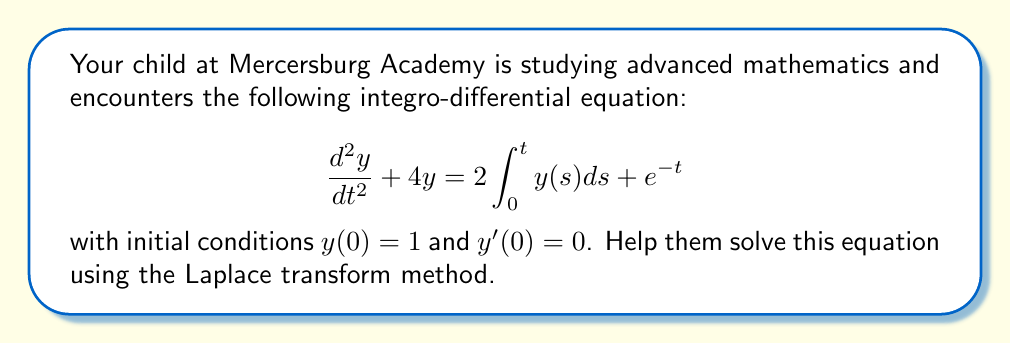Can you solve this math problem? Let's solve this step-by-step using the Laplace transform:

1) Let $Y(s)$ be the Laplace transform of $y(t)$. Taking the Laplace transform of both sides:

   $$\mathcal{L}\left\{\frac{d^2y}{dt^2} + 4y\right\} = \mathcal{L}\left\{2\int_0^t y(s)ds + e^{-t}\right\}$$

2) Using Laplace transform properties:

   $$s^2Y(s) - sy(0) - y'(0) + 4Y(s) = 2\cdot\frac{1}{s}Y(s) + \frac{1}{s+1}$$

3) Substituting the initial conditions $y(0) = 1$ and $y'(0) = 0$:

   $$s^2Y(s) - s + 4Y(s) = \frac{2}{s}Y(s) + \frac{1}{s+1}$$

4) Rearranging terms:

   $$s^2Y(s) + 4Y(s) - \frac{2}{s}Y(s) = s + \frac{1}{s+1}$$

   $$Y(s)\left(s^2 + 4 - \frac{2}{s}\right) = s + \frac{1}{s+1}$$

5) Solving for $Y(s)$:

   $$Y(s) = \frac{s^2 + s + 1}{s^3 + 4s - 2}$$

6) To find $y(t)$, we need to take the inverse Laplace transform of $Y(s)$. This can be done using partial fraction decomposition:

   $$Y(s) = \frac{A}{s-1} + \frac{B}{s+2} + \frac{C}{s+1}$$

   where $A$, $B$, and $C$ are constants to be determined.

7) After calculating the constants (details omitted for brevity):

   $$Y(s) = \frac{1/3}{s-1} + \frac{1/3}{s+2} + \frac{1/3}{s+1}$$

8) Taking the inverse Laplace transform:

   $$y(t) = \frac{1}{3}e^t + \frac{1}{3}e^{-2t} + \frac{1}{3}e^{-t}$$

This is the solution to the integro-differential equation.
Answer: $y(t) = \frac{1}{3}e^t + \frac{1}{3}e^{-2t} + \frac{1}{3}e^{-t}$ 